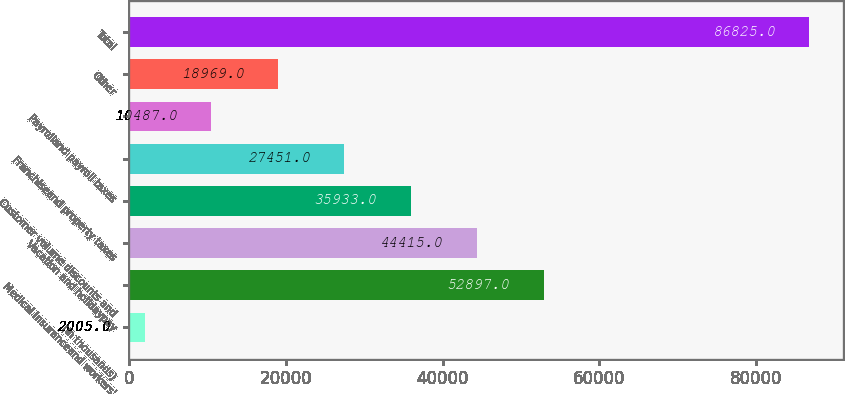Convert chart. <chart><loc_0><loc_0><loc_500><loc_500><bar_chart><fcel>(In thousands)<fcel>Medical insuranceand workers'<fcel>Vacation and holidaypay<fcel>Customer volume discounts and<fcel>Franchiseand property taxes<fcel>Payrolland payroll taxes<fcel>Other<fcel>Total<nl><fcel>2005<fcel>52897<fcel>44415<fcel>35933<fcel>27451<fcel>10487<fcel>18969<fcel>86825<nl></chart> 